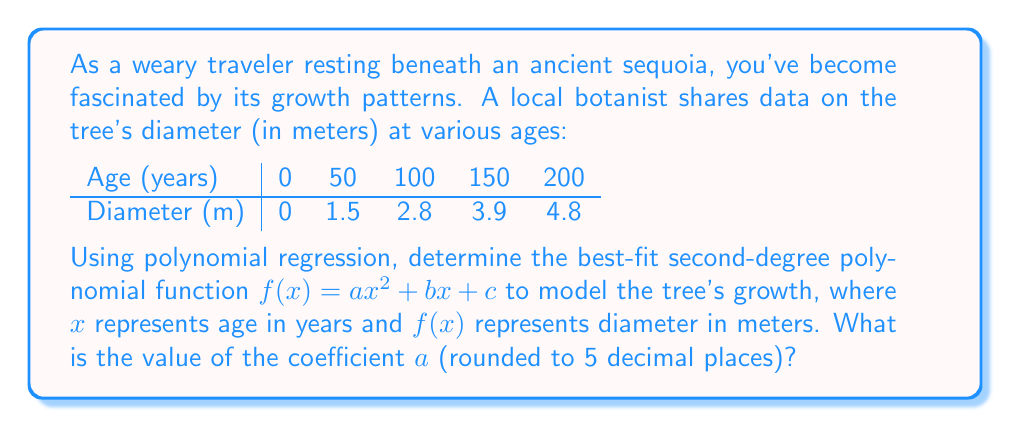Provide a solution to this math problem. To find the best-fit second-degree polynomial, we'll use the method of least squares. Let's follow these steps:

1) We need to solve the normal equations:
   $$\begin{align}
   \sum y &= an\sum x^2 + b\sum x + nc \\
   \sum xy &= a\sum x^3 + b\sum x^2 + c\sum x \\
   \sum x^2y &= a\sum x^4 + b\sum x^3 + c\sum x^2
   \end{align}$$

2) Calculate the necessary sums:
   $n = 5$
   $\sum x = 0 + 50 + 100 + 150 + 200 = 500$
   $\sum x^2 = 0^2 + 50^2 + 100^2 + 150^2 + 200^2 = 87,500$
   $\sum x^3 = 0^3 + 50^3 + 100^3 + 150^3 + 200^3 = 8,750,000$
   $\sum x^4 = 0^4 + 50^4 + 100^4 + 150^4 + 200^4 = 1,093,750,000$
   $\sum y = 0 + 1.5 + 2.8 + 3.9 + 4.8 = 13$
   $\sum xy = 0(0) + 50(1.5) + 100(2.8) + 150(3.9) + 200(4.8) = 1,895$
   $\sum x^2y = 0^2(0) + 50^2(1.5) + 100^2(2.8) + 150^2(3.9) + 200^2(4.8) = 280,750$

3) Substitute these values into the normal equations:
   $$\begin{align}
   13 &= 87,500a + 500b + 5c \\
   1,895 &= 8,750,000a + 87,500b + 500c \\
   280,750 &= 1,093,750,000a + 8,750,000b + 87,500c
   \end{align}$$

4) Solve this system of equations. This can be done using matrix methods or elimination. After solving, we get:

   $a \approx -0.00002857$
   $b \approx 0.03086$
   $c \approx 0.09714$

5) Round $a$ to 5 decimal places: $-0.00003$

Therefore, the best-fit second-degree polynomial is approximately:
$f(x) = -0.00003x^2 + 0.03086x + 0.09714$
Answer: $-0.00003$ 